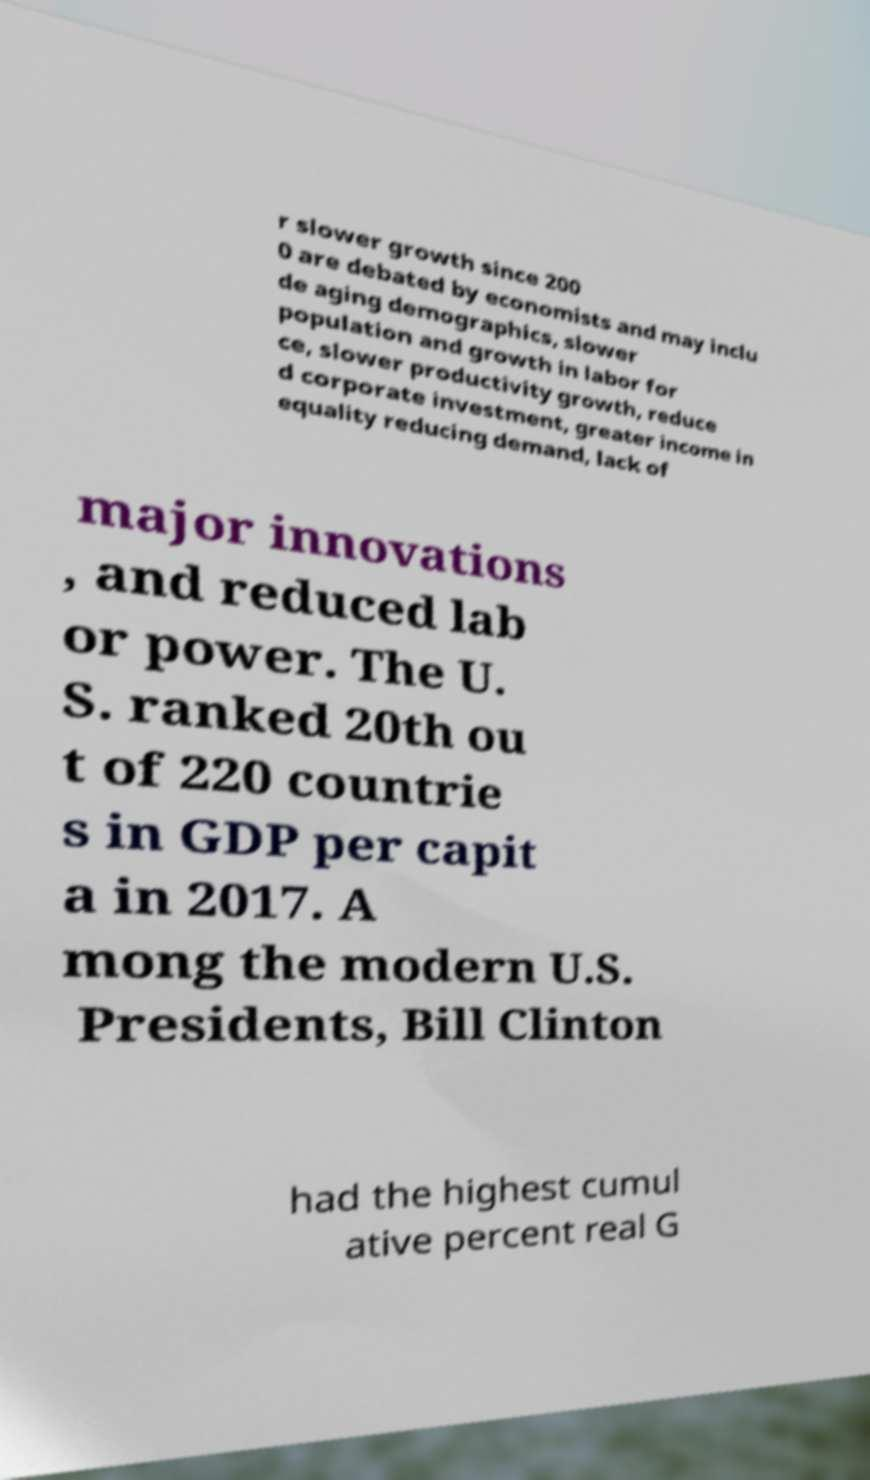Could you assist in decoding the text presented in this image and type it out clearly? r slower growth since 200 0 are debated by economists and may inclu de aging demographics, slower population and growth in labor for ce, slower productivity growth, reduce d corporate investment, greater income in equality reducing demand, lack of major innovations , and reduced lab or power. The U. S. ranked 20th ou t of 220 countrie s in GDP per capit a in 2017. A mong the modern U.S. Presidents, Bill Clinton had the highest cumul ative percent real G 